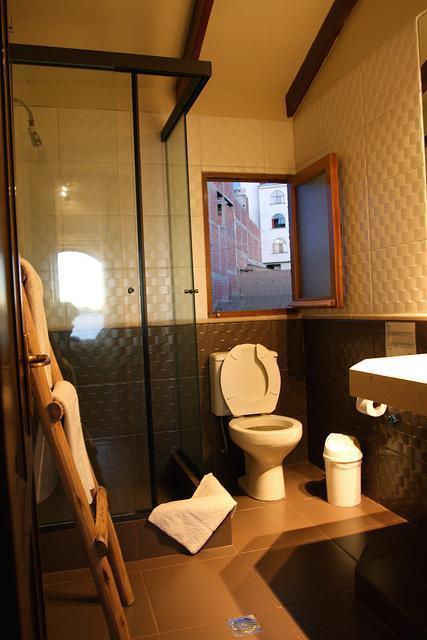How many clock faces are on this structure?
Give a very brief answer. 0. 